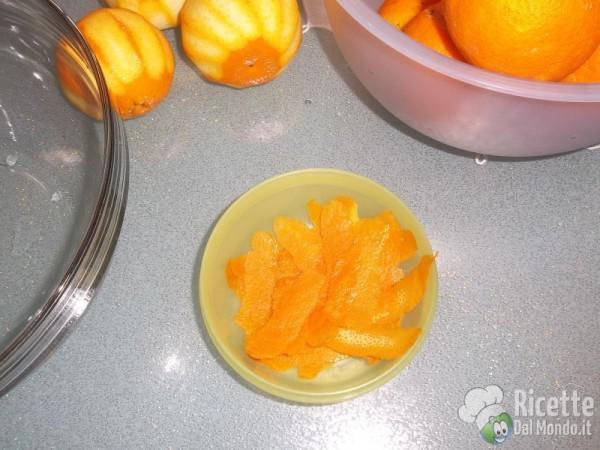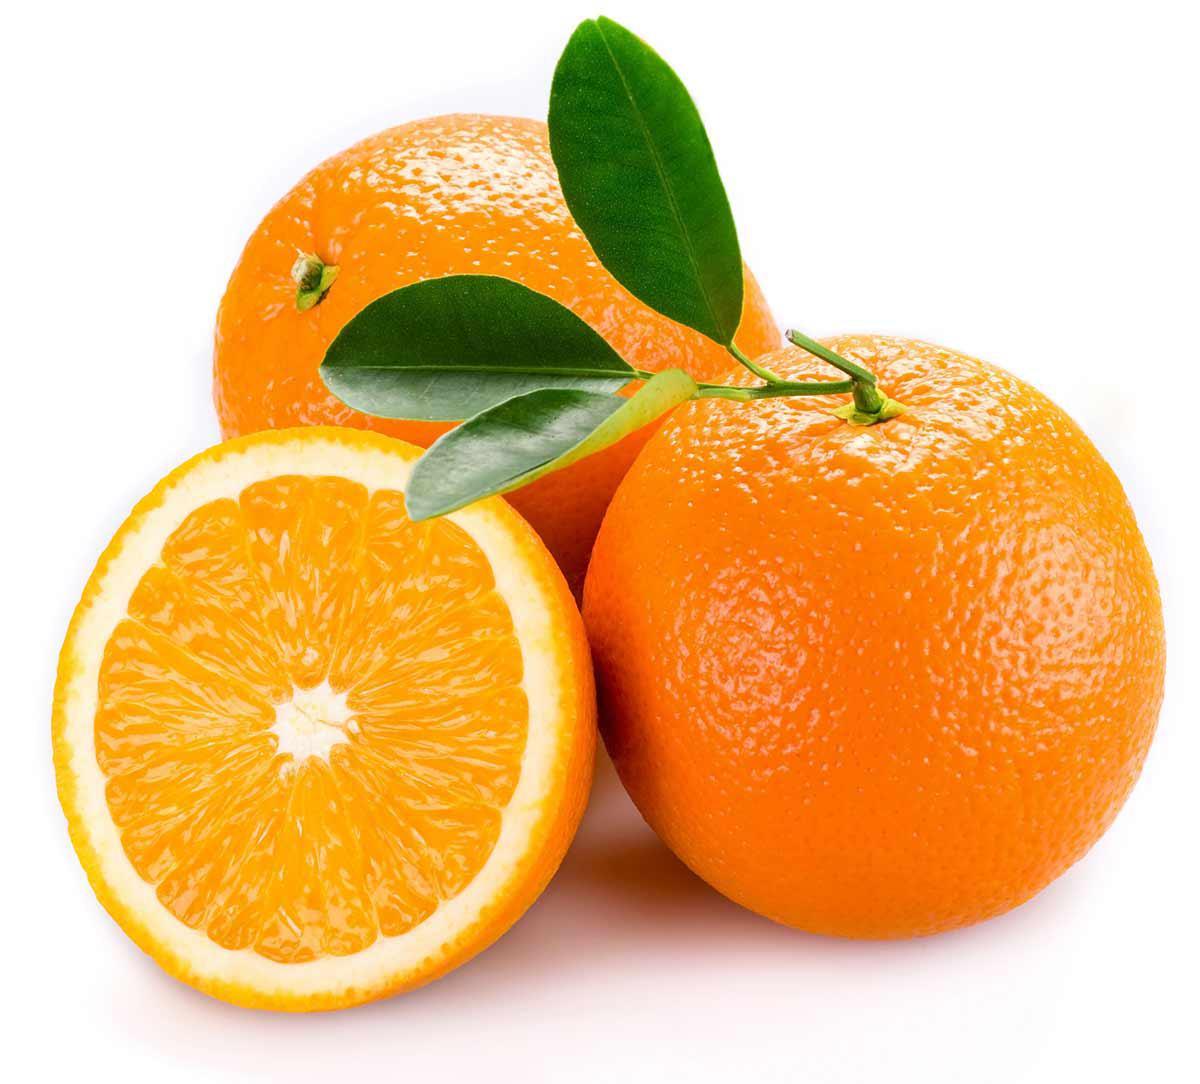The first image is the image on the left, the second image is the image on the right. Evaluate the accuracy of this statement regarding the images: "One of the images has two whole oranges with no partially cut oranges.". Is it true? Answer yes or no. No. The first image is the image on the left, the second image is the image on the right. Examine the images to the left and right. Is the description "There are four unpeeled oranges in the pair of images." accurate? Answer yes or no. No. 